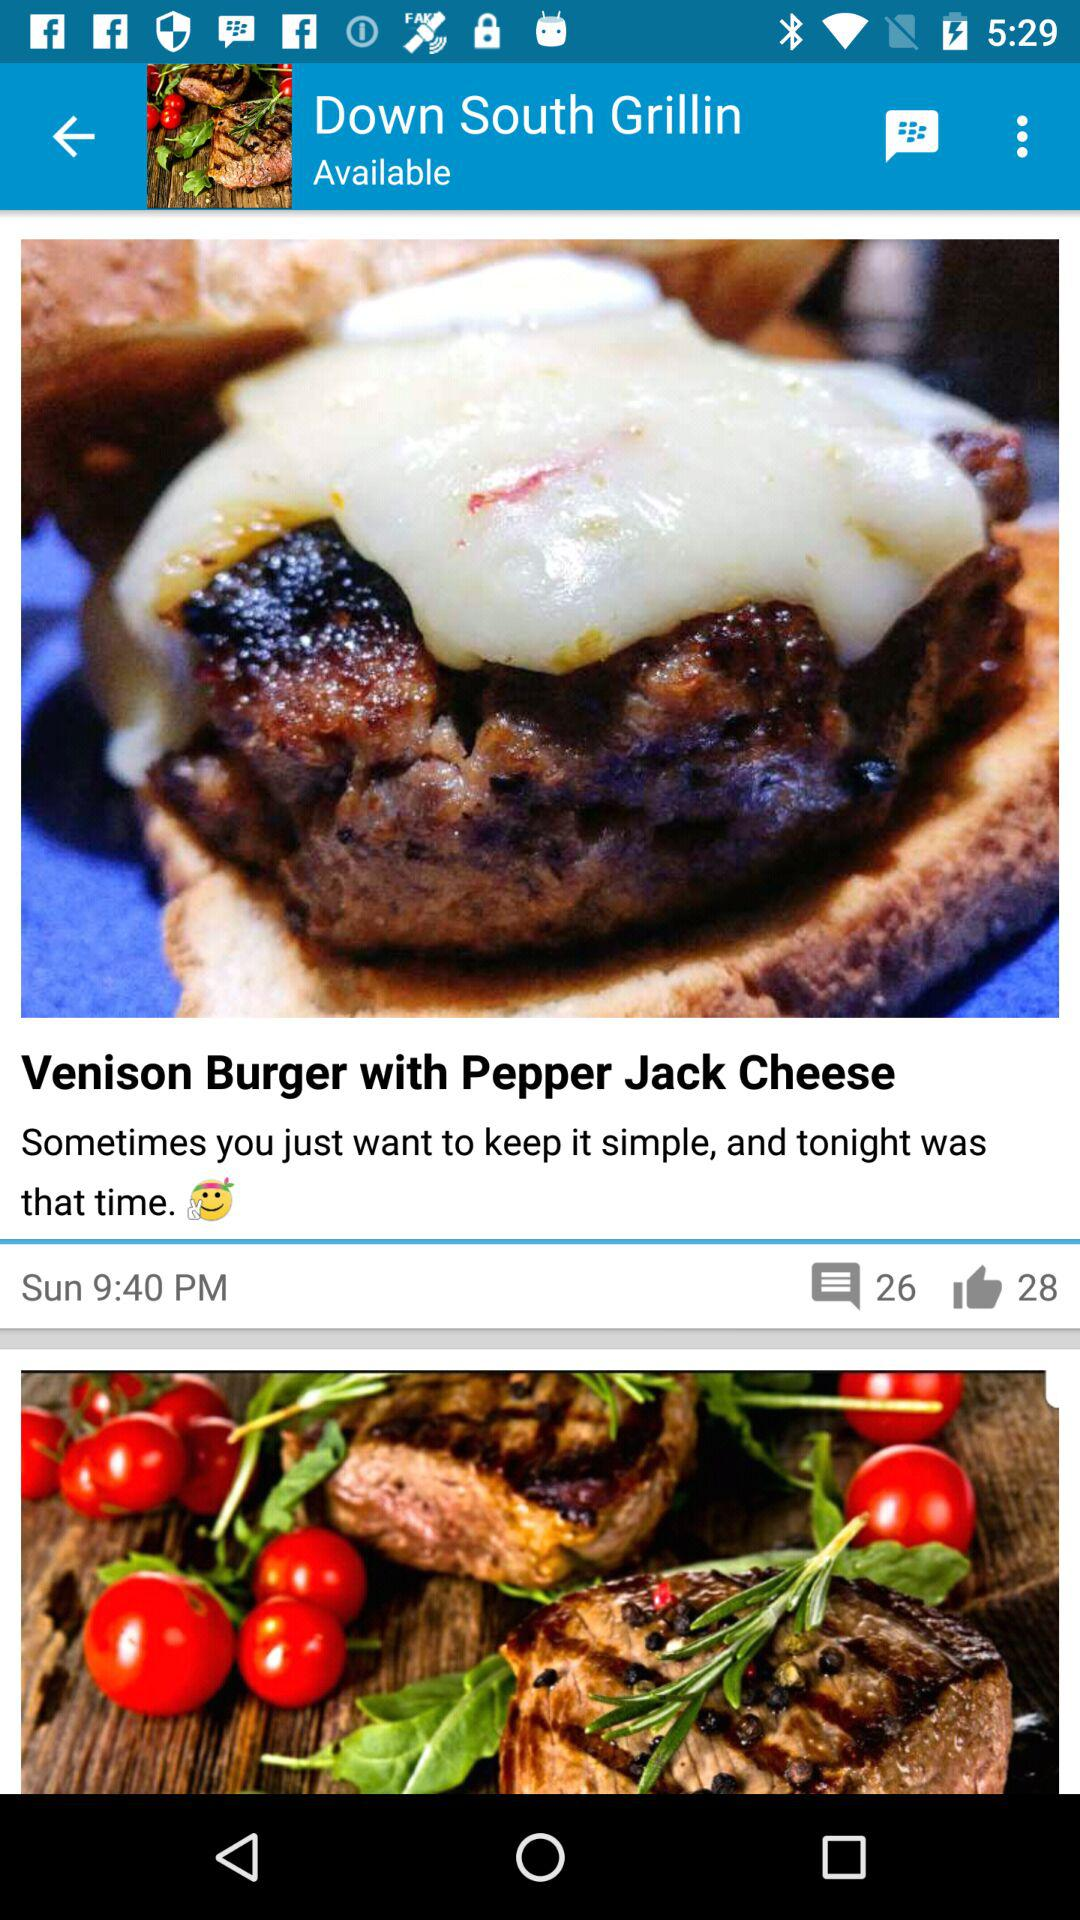What is the name of the food? The name of the food is "Venison Burger with Pepper Jack Cheese". 